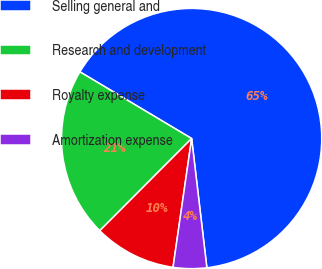<chart> <loc_0><loc_0><loc_500><loc_500><pie_chart><fcel>Selling general and<fcel>Research and development<fcel>Royalty expense<fcel>Amortization expense<nl><fcel>64.57%<fcel>21.09%<fcel>10.19%<fcel>4.15%<nl></chart> 